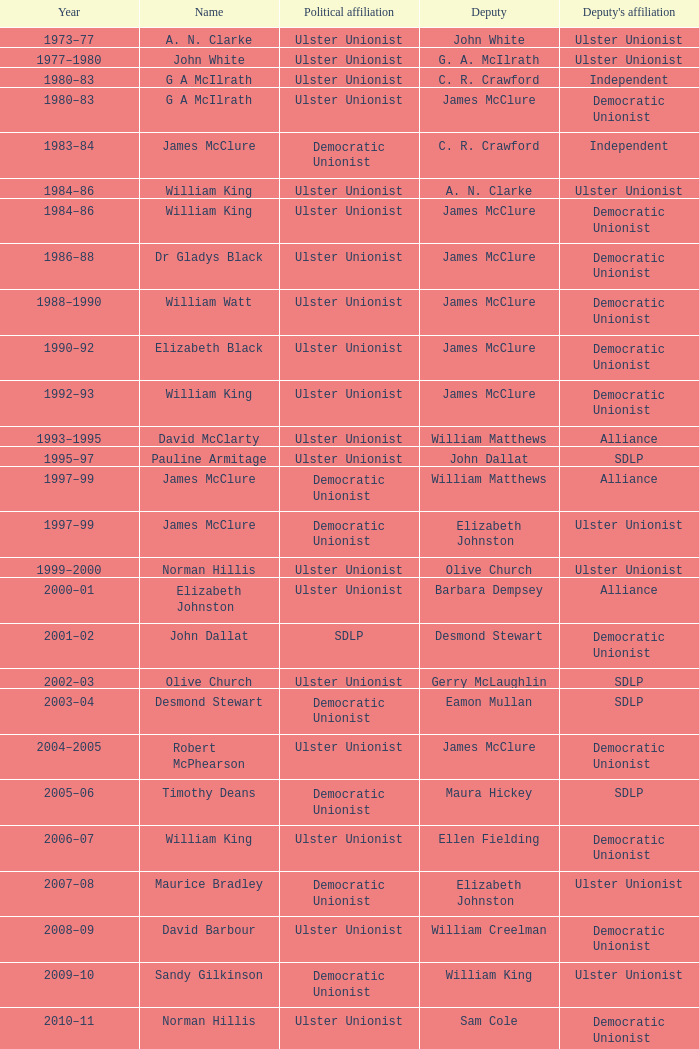What Year was james mcclure Deputy, and the Name is robert mcphearson? 2004–2005. Can you give me this table as a dict? {'header': ['Year', 'Name', 'Political affiliation', 'Deputy', "Deputy's affiliation"], 'rows': [['1973–77', 'A. N. Clarke', 'Ulster Unionist', 'John White', 'Ulster Unionist'], ['1977–1980', 'John White', 'Ulster Unionist', 'G. A. McIlrath', 'Ulster Unionist'], ['1980–83', 'G A McIlrath', 'Ulster Unionist', 'C. R. Crawford', 'Independent'], ['1980–83', 'G A McIlrath', 'Ulster Unionist', 'James McClure', 'Democratic Unionist'], ['1983–84', 'James McClure', 'Democratic Unionist', 'C. R. Crawford', 'Independent'], ['1984–86', 'William King', 'Ulster Unionist', 'A. N. Clarke', 'Ulster Unionist'], ['1984–86', 'William King', 'Ulster Unionist', 'James McClure', 'Democratic Unionist'], ['1986–88', 'Dr Gladys Black', 'Ulster Unionist', 'James McClure', 'Democratic Unionist'], ['1988–1990', 'William Watt', 'Ulster Unionist', 'James McClure', 'Democratic Unionist'], ['1990–92', 'Elizabeth Black', 'Ulster Unionist', 'James McClure', 'Democratic Unionist'], ['1992–93', 'William King', 'Ulster Unionist', 'James McClure', 'Democratic Unionist'], ['1993–1995', 'David McClarty', 'Ulster Unionist', 'William Matthews', 'Alliance'], ['1995–97', 'Pauline Armitage', 'Ulster Unionist', 'John Dallat', 'SDLP'], ['1997–99', 'James McClure', 'Democratic Unionist', 'William Matthews', 'Alliance'], ['1997–99', 'James McClure', 'Democratic Unionist', 'Elizabeth Johnston', 'Ulster Unionist'], ['1999–2000', 'Norman Hillis', 'Ulster Unionist', 'Olive Church', 'Ulster Unionist'], ['2000–01', 'Elizabeth Johnston', 'Ulster Unionist', 'Barbara Dempsey', 'Alliance'], ['2001–02', 'John Dallat', 'SDLP', 'Desmond Stewart', 'Democratic Unionist'], ['2002–03', 'Olive Church', 'Ulster Unionist', 'Gerry McLaughlin', 'SDLP'], ['2003–04', 'Desmond Stewart', 'Democratic Unionist', 'Eamon Mullan', 'SDLP'], ['2004–2005', 'Robert McPhearson', 'Ulster Unionist', 'James McClure', 'Democratic Unionist'], ['2005–06', 'Timothy Deans', 'Democratic Unionist', 'Maura Hickey', 'SDLP'], ['2006–07', 'William King', 'Ulster Unionist', 'Ellen Fielding', 'Democratic Unionist'], ['2007–08', 'Maurice Bradley', 'Democratic Unionist', 'Elizabeth Johnston', 'Ulster Unionist'], ['2008–09', 'David Barbour', 'Ulster Unionist', 'William Creelman', 'Democratic Unionist'], ['2009–10', 'Sandy Gilkinson', 'Democratic Unionist', 'William King', 'Ulster Unionist'], ['2010–11', 'Norman Hillis', 'Ulster Unionist', 'Sam Cole', 'Democratic Unionist'], ['2011–12', 'Maurice Bradley', 'Democratic Unionist', 'William King', 'Ulster Unionist'], ['2012–13', 'Sam Cole', 'Democratic Unionist', 'Maura Hickey', 'SDLP'], ['2013–14', 'David Harding', 'Ulster Unionist', 'Mark Fielding', 'Democratic Unionist']]} 